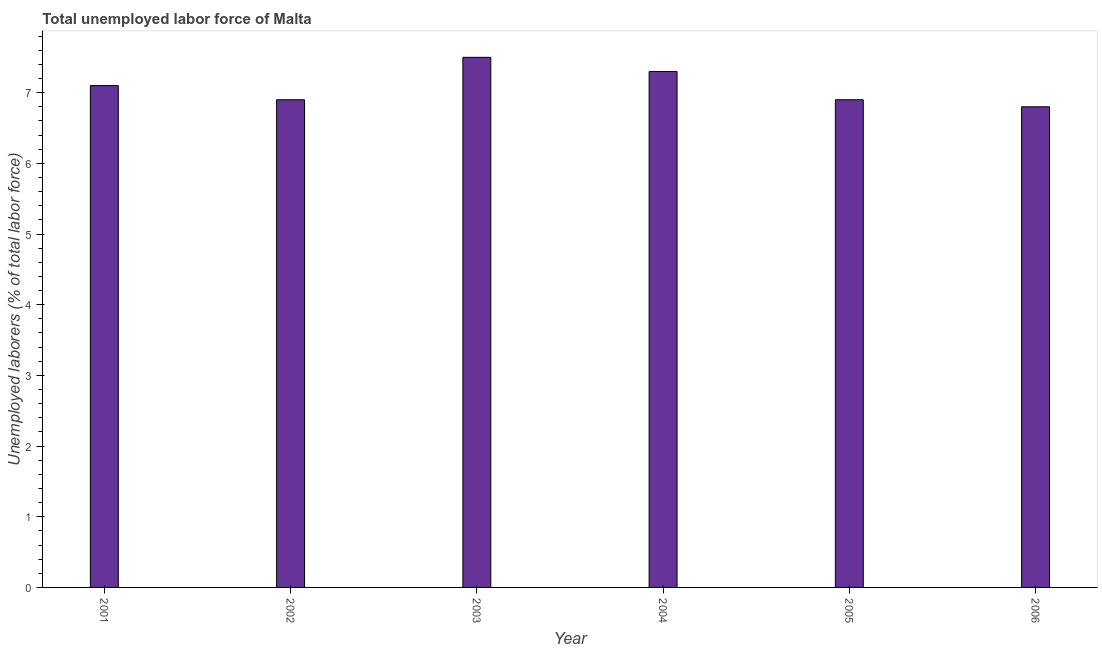Does the graph contain any zero values?
Your answer should be compact. No. Does the graph contain grids?
Provide a succinct answer. No. What is the title of the graph?
Provide a short and direct response. Total unemployed labor force of Malta. What is the label or title of the Y-axis?
Offer a terse response. Unemployed laborers (% of total labor force). What is the total unemployed labour force in 2003?
Give a very brief answer. 7.5. Across all years, what is the minimum total unemployed labour force?
Offer a very short reply. 6.8. In which year was the total unemployed labour force maximum?
Your answer should be compact. 2003. What is the sum of the total unemployed labour force?
Make the answer very short. 42.5. What is the difference between the total unemployed labour force in 2001 and 2002?
Make the answer very short. 0.2. What is the average total unemployed labour force per year?
Your response must be concise. 7.08. Do a majority of the years between 2001 and 2006 (inclusive) have total unemployed labour force greater than 4.6 %?
Provide a succinct answer. Yes. What is the ratio of the total unemployed labour force in 2002 to that in 2005?
Ensure brevity in your answer.  1. Is the sum of the total unemployed labour force in 2002 and 2003 greater than the maximum total unemployed labour force across all years?
Your answer should be compact. Yes. How many bars are there?
Your answer should be compact. 6. How many years are there in the graph?
Offer a terse response. 6. What is the difference between two consecutive major ticks on the Y-axis?
Ensure brevity in your answer.  1. Are the values on the major ticks of Y-axis written in scientific E-notation?
Provide a short and direct response. No. What is the Unemployed laborers (% of total labor force) in 2001?
Give a very brief answer. 7.1. What is the Unemployed laborers (% of total labor force) in 2002?
Provide a short and direct response. 6.9. What is the Unemployed laborers (% of total labor force) in 2004?
Provide a short and direct response. 7.3. What is the Unemployed laborers (% of total labor force) of 2005?
Make the answer very short. 6.9. What is the Unemployed laborers (% of total labor force) of 2006?
Your response must be concise. 6.8. What is the difference between the Unemployed laborers (% of total labor force) in 2001 and 2002?
Make the answer very short. 0.2. What is the difference between the Unemployed laborers (% of total labor force) in 2001 and 2003?
Make the answer very short. -0.4. What is the difference between the Unemployed laborers (% of total labor force) in 2001 and 2006?
Offer a very short reply. 0.3. What is the difference between the Unemployed laborers (% of total labor force) in 2002 and 2003?
Make the answer very short. -0.6. What is the difference between the Unemployed laborers (% of total labor force) in 2002 and 2005?
Keep it short and to the point. 0. What is the difference between the Unemployed laborers (% of total labor force) in 2002 and 2006?
Your answer should be compact. 0.1. What is the difference between the Unemployed laborers (% of total labor force) in 2004 and 2005?
Make the answer very short. 0.4. What is the difference between the Unemployed laborers (% of total labor force) in 2005 and 2006?
Provide a short and direct response. 0.1. What is the ratio of the Unemployed laborers (% of total labor force) in 2001 to that in 2003?
Your response must be concise. 0.95. What is the ratio of the Unemployed laborers (% of total labor force) in 2001 to that in 2006?
Give a very brief answer. 1.04. What is the ratio of the Unemployed laborers (% of total labor force) in 2002 to that in 2003?
Offer a very short reply. 0.92. What is the ratio of the Unemployed laborers (% of total labor force) in 2002 to that in 2004?
Your response must be concise. 0.94. What is the ratio of the Unemployed laborers (% of total labor force) in 2002 to that in 2005?
Provide a succinct answer. 1. What is the ratio of the Unemployed laborers (% of total labor force) in 2002 to that in 2006?
Give a very brief answer. 1.01. What is the ratio of the Unemployed laborers (% of total labor force) in 2003 to that in 2004?
Keep it short and to the point. 1.03. What is the ratio of the Unemployed laborers (% of total labor force) in 2003 to that in 2005?
Offer a very short reply. 1.09. What is the ratio of the Unemployed laborers (% of total labor force) in 2003 to that in 2006?
Ensure brevity in your answer.  1.1. What is the ratio of the Unemployed laborers (% of total labor force) in 2004 to that in 2005?
Offer a very short reply. 1.06. What is the ratio of the Unemployed laborers (% of total labor force) in 2004 to that in 2006?
Your answer should be compact. 1.07. 